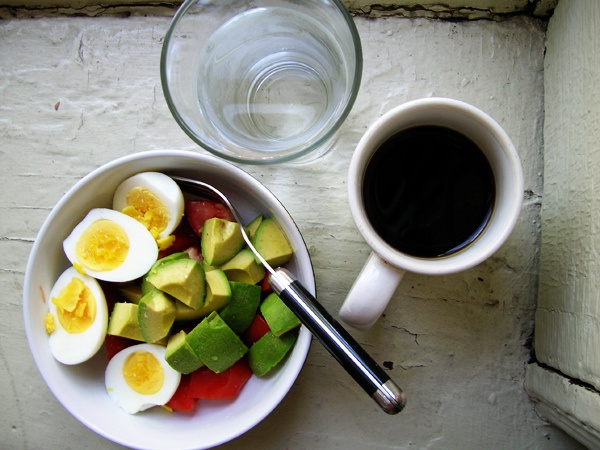Describe the objects in this image and their specific colors. I can see bowl in black, lightgray, olive, and darkgray tones, cup in black, darkgray, and lightgray tones, cup in black, lightgray, darkgray, and gray tones, and spoon in black, white, and gray tones in this image. 